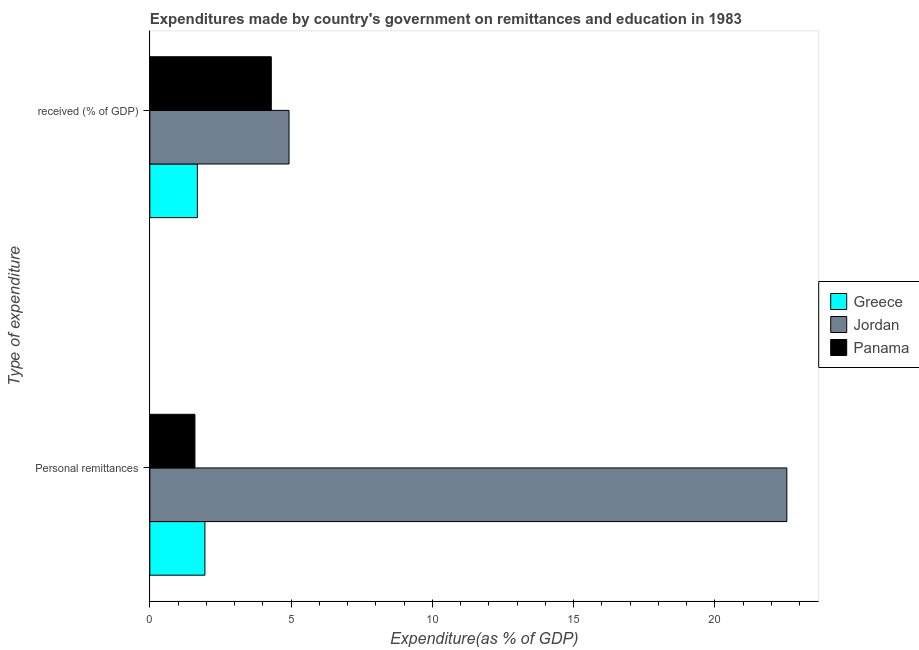How many different coloured bars are there?
Your answer should be very brief. 3. How many groups of bars are there?
Your answer should be compact. 2. Are the number of bars per tick equal to the number of legend labels?
Give a very brief answer. Yes. What is the label of the 1st group of bars from the top?
Keep it short and to the point.  received (% of GDP). What is the expenditure in education in Jordan?
Provide a short and direct response. 4.93. Across all countries, what is the maximum expenditure in education?
Give a very brief answer. 4.93. Across all countries, what is the minimum expenditure in personal remittances?
Give a very brief answer. 1.6. In which country was the expenditure in personal remittances maximum?
Your response must be concise. Jordan. In which country was the expenditure in education minimum?
Give a very brief answer. Greece. What is the total expenditure in education in the graph?
Offer a terse response. 10.91. What is the difference between the expenditure in education in Greece and that in Panama?
Make the answer very short. -2.62. What is the difference between the expenditure in education in Panama and the expenditure in personal remittances in Jordan?
Provide a succinct answer. -18.25. What is the average expenditure in education per country?
Your answer should be very brief. 3.64. What is the difference between the expenditure in personal remittances and expenditure in education in Jordan?
Keep it short and to the point. 17.62. What is the ratio of the expenditure in personal remittances in Jordan to that in Greece?
Make the answer very short. 11.56. Is the expenditure in personal remittances in Greece less than that in Jordan?
Offer a terse response. Yes. In how many countries, is the expenditure in education greater than the average expenditure in education taken over all countries?
Provide a succinct answer. 2. What does the 2nd bar from the top in Personal remittances represents?
Your response must be concise. Jordan. What is the difference between two consecutive major ticks on the X-axis?
Keep it short and to the point. 5. Does the graph contain any zero values?
Provide a succinct answer. No. Does the graph contain grids?
Keep it short and to the point. No. Where does the legend appear in the graph?
Give a very brief answer. Center right. What is the title of the graph?
Make the answer very short. Expenditures made by country's government on remittances and education in 1983. What is the label or title of the X-axis?
Make the answer very short. Expenditure(as % of GDP). What is the label or title of the Y-axis?
Make the answer very short. Type of expenditure. What is the Expenditure(as % of GDP) of Greece in Personal remittances?
Your answer should be very brief. 1.95. What is the Expenditure(as % of GDP) of Jordan in Personal remittances?
Offer a very short reply. 22.55. What is the Expenditure(as % of GDP) of Panama in Personal remittances?
Ensure brevity in your answer.  1.6. What is the Expenditure(as % of GDP) of Greece in  received (% of GDP)?
Offer a terse response. 1.68. What is the Expenditure(as % of GDP) in Jordan in  received (% of GDP)?
Offer a terse response. 4.93. What is the Expenditure(as % of GDP) in Panama in  received (% of GDP)?
Offer a terse response. 4.3. Across all Type of expenditure, what is the maximum Expenditure(as % of GDP) of Greece?
Make the answer very short. 1.95. Across all Type of expenditure, what is the maximum Expenditure(as % of GDP) of Jordan?
Offer a terse response. 22.55. Across all Type of expenditure, what is the maximum Expenditure(as % of GDP) of Panama?
Ensure brevity in your answer.  4.3. Across all Type of expenditure, what is the minimum Expenditure(as % of GDP) of Greece?
Provide a short and direct response. 1.68. Across all Type of expenditure, what is the minimum Expenditure(as % of GDP) in Jordan?
Your answer should be compact. 4.93. Across all Type of expenditure, what is the minimum Expenditure(as % of GDP) of Panama?
Offer a terse response. 1.6. What is the total Expenditure(as % of GDP) in Greece in the graph?
Provide a short and direct response. 3.63. What is the total Expenditure(as % of GDP) in Jordan in the graph?
Give a very brief answer. 27.48. What is the total Expenditure(as % of GDP) of Panama in the graph?
Make the answer very short. 5.9. What is the difference between the Expenditure(as % of GDP) of Greece in Personal remittances and that in  received (% of GDP)?
Give a very brief answer. 0.27. What is the difference between the Expenditure(as % of GDP) of Jordan in Personal remittances and that in  received (% of GDP)?
Make the answer very short. 17.62. What is the difference between the Expenditure(as % of GDP) of Panama in Personal remittances and that in  received (% of GDP)?
Offer a terse response. -2.7. What is the difference between the Expenditure(as % of GDP) of Greece in Personal remittances and the Expenditure(as % of GDP) of Jordan in  received (% of GDP)?
Offer a very short reply. -2.98. What is the difference between the Expenditure(as % of GDP) in Greece in Personal remittances and the Expenditure(as % of GDP) in Panama in  received (% of GDP)?
Your answer should be very brief. -2.35. What is the difference between the Expenditure(as % of GDP) in Jordan in Personal remittances and the Expenditure(as % of GDP) in Panama in  received (% of GDP)?
Make the answer very short. 18.25. What is the average Expenditure(as % of GDP) of Greece per Type of expenditure?
Make the answer very short. 1.82. What is the average Expenditure(as % of GDP) in Jordan per Type of expenditure?
Ensure brevity in your answer.  13.74. What is the average Expenditure(as % of GDP) in Panama per Type of expenditure?
Your response must be concise. 2.95. What is the difference between the Expenditure(as % of GDP) in Greece and Expenditure(as % of GDP) in Jordan in Personal remittances?
Keep it short and to the point. -20.6. What is the difference between the Expenditure(as % of GDP) of Greece and Expenditure(as % of GDP) of Panama in Personal remittances?
Provide a succinct answer. 0.35. What is the difference between the Expenditure(as % of GDP) of Jordan and Expenditure(as % of GDP) of Panama in Personal remittances?
Your answer should be very brief. 20.95. What is the difference between the Expenditure(as % of GDP) of Greece and Expenditure(as % of GDP) of Jordan in  received (% of GDP)?
Offer a very short reply. -3.25. What is the difference between the Expenditure(as % of GDP) of Greece and Expenditure(as % of GDP) of Panama in  received (% of GDP)?
Make the answer very short. -2.62. What is the difference between the Expenditure(as % of GDP) in Jordan and Expenditure(as % of GDP) in Panama in  received (% of GDP)?
Your answer should be very brief. 0.63. What is the ratio of the Expenditure(as % of GDP) of Greece in Personal remittances to that in  received (% of GDP)?
Your response must be concise. 1.16. What is the ratio of the Expenditure(as % of GDP) of Jordan in Personal remittances to that in  received (% of GDP)?
Give a very brief answer. 4.58. What is the ratio of the Expenditure(as % of GDP) in Panama in Personal remittances to that in  received (% of GDP)?
Offer a very short reply. 0.37. What is the difference between the highest and the second highest Expenditure(as % of GDP) in Greece?
Give a very brief answer. 0.27. What is the difference between the highest and the second highest Expenditure(as % of GDP) of Jordan?
Your response must be concise. 17.62. What is the difference between the highest and the second highest Expenditure(as % of GDP) in Panama?
Your response must be concise. 2.7. What is the difference between the highest and the lowest Expenditure(as % of GDP) of Greece?
Give a very brief answer. 0.27. What is the difference between the highest and the lowest Expenditure(as % of GDP) in Jordan?
Provide a short and direct response. 17.62. What is the difference between the highest and the lowest Expenditure(as % of GDP) in Panama?
Give a very brief answer. 2.7. 